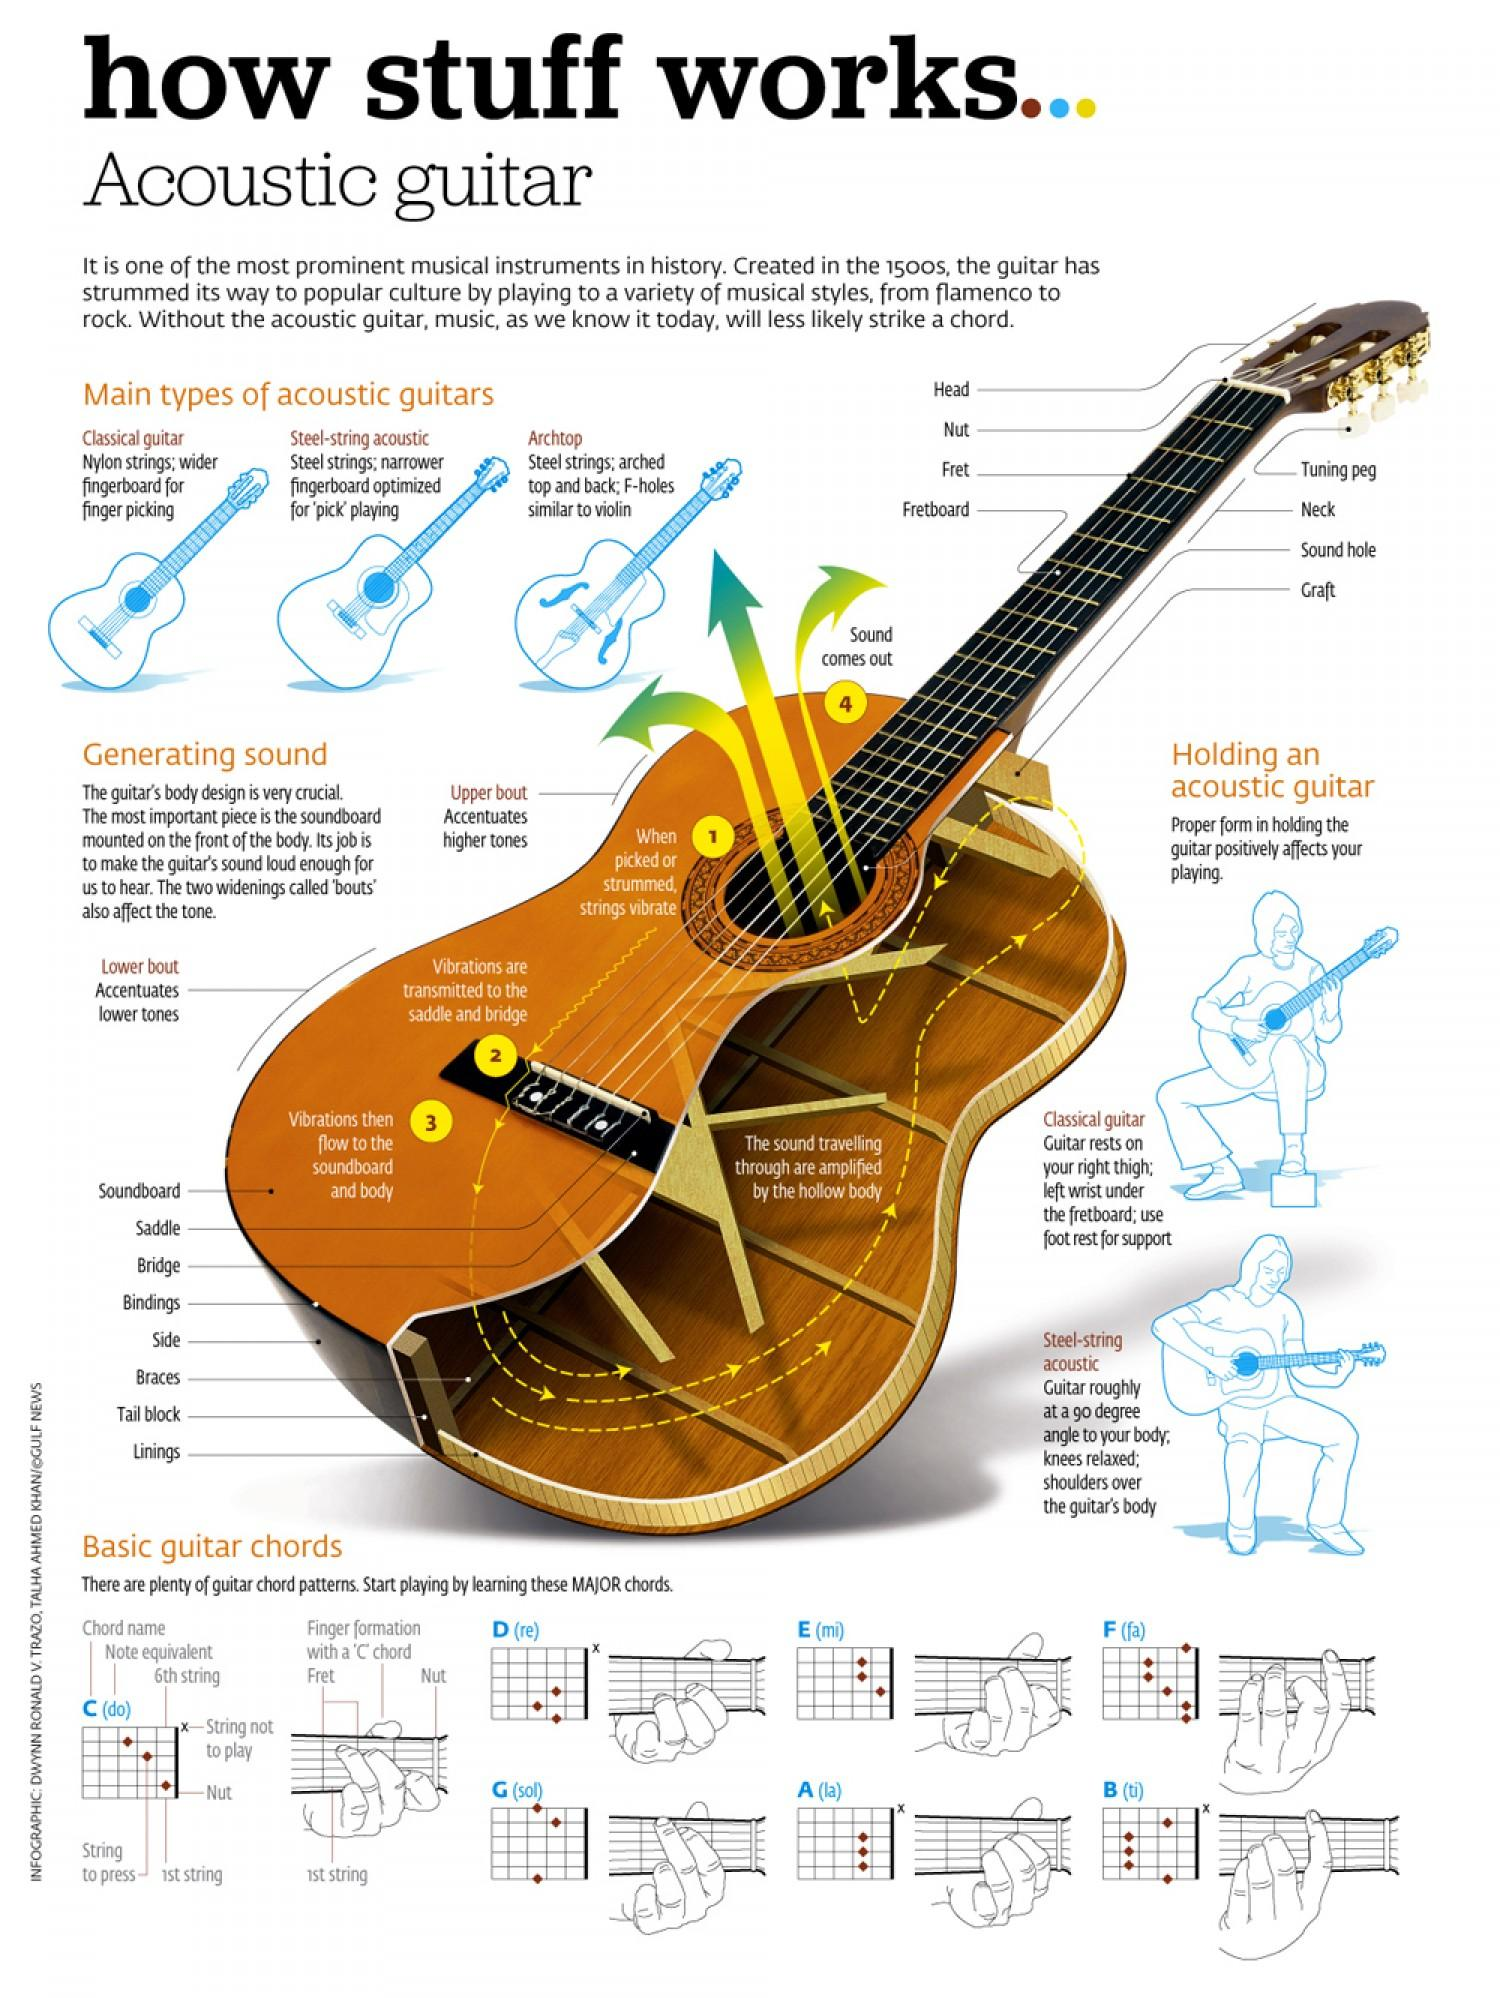Draw attention to some important aspects in this diagram. The Archtop acoustic guitar is known for its distinctive feature of having F-holes. The strings of a guitar vibrate due to the action of being picked or strummed. The function of the upper bout is to accentuate higher tones. The lower bout is a structural component of certain musical instruments, such as stringed instruments, that serves to accentuate the lower tones produced by the instrument. Classical guitars are acoustic instruments with nylon strings, as opposed to the steel strings found on other types of acoustic guitars such as the acoustic-electric or flat-top guitar. 